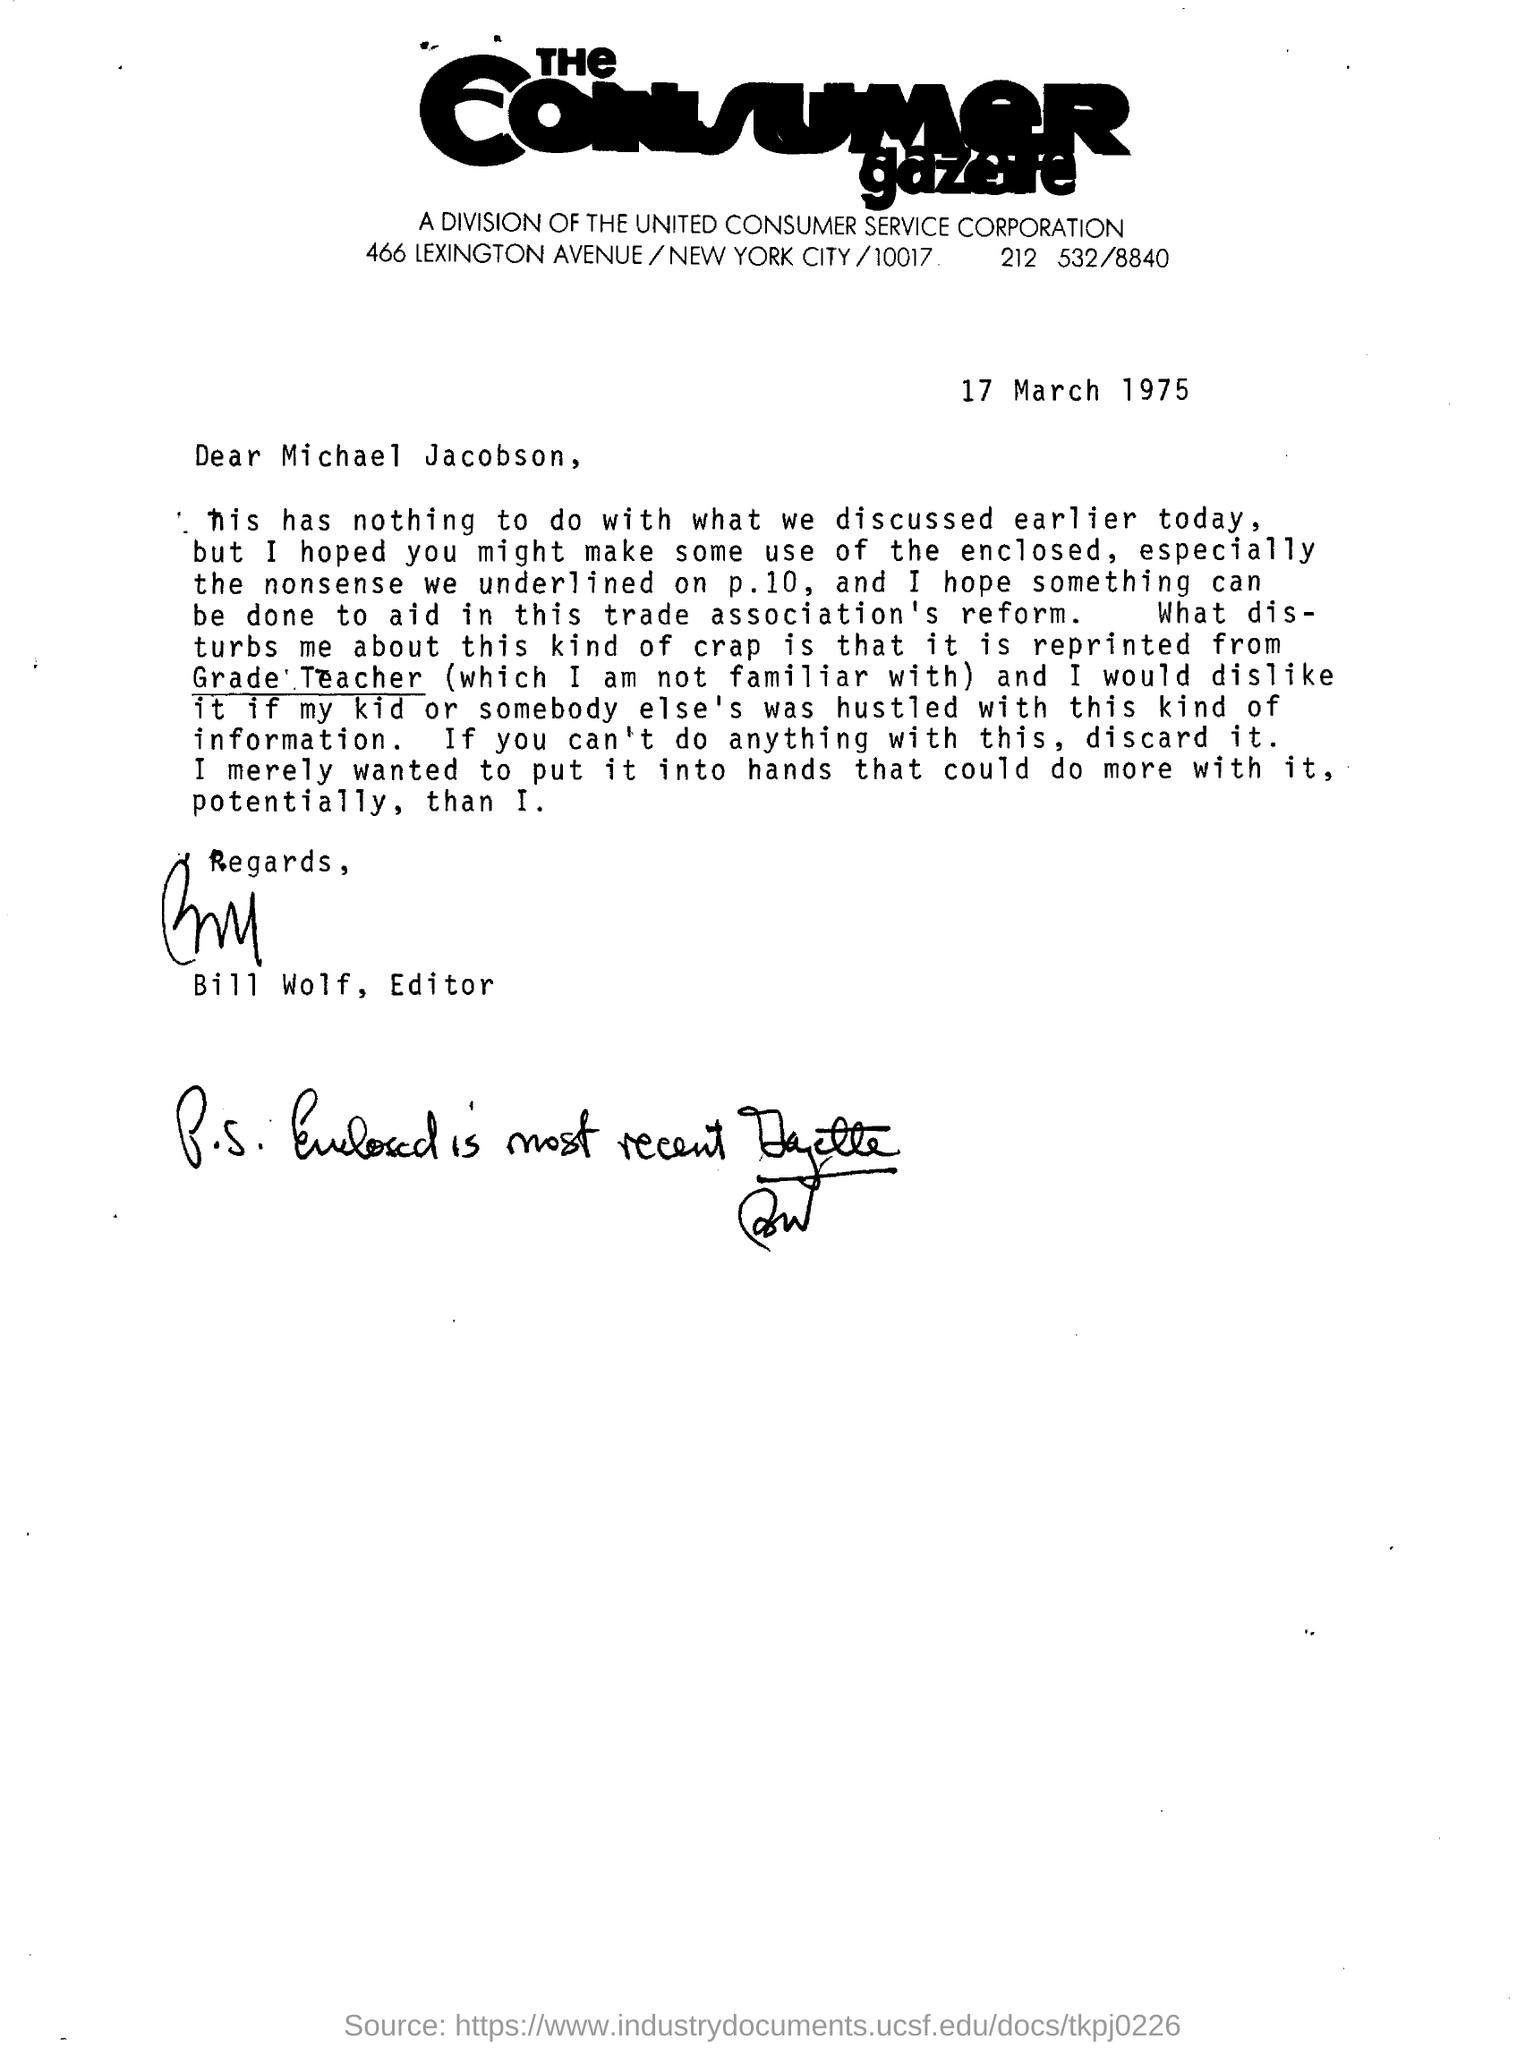Indicate a few pertinent items in this graphic. This letter was written for Michael Jacobson. This letter was written on March 17, 1975. The letter is written under the umbrella of the United Consumer Service Corporation. The editor who signed this letter is Bill Wolf. 